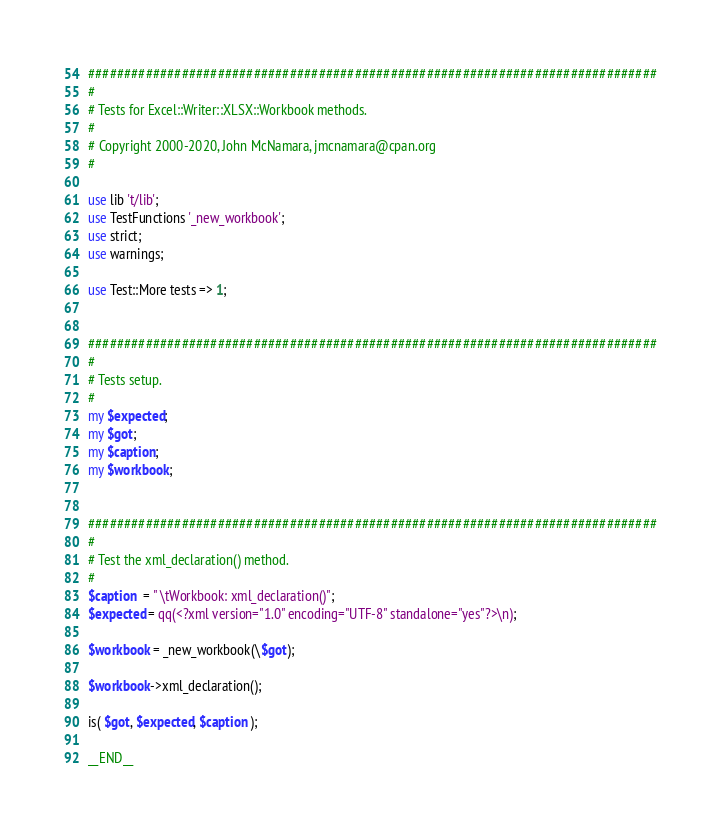Convert code to text. <code><loc_0><loc_0><loc_500><loc_500><_Perl_>###############################################################################
#
# Tests for Excel::Writer::XLSX::Workbook methods.
#
# Copyright 2000-2020, John McNamara, jmcnamara@cpan.org
#

use lib 't/lib';
use TestFunctions '_new_workbook';
use strict;
use warnings;

use Test::More tests => 1;


###############################################################################
#
# Tests setup.
#
my $expected;
my $got;
my $caption;
my $workbook;


###############################################################################
#
# Test the xml_declaration() method.
#
$caption  = " \tWorkbook: xml_declaration()";
$expected = qq(<?xml version="1.0" encoding="UTF-8" standalone="yes"?>\n);

$workbook = _new_workbook(\$got);

$workbook->xml_declaration();

is( $got, $expected, $caption );

__END__


</code> 